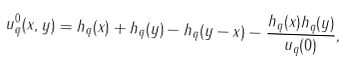<formula> <loc_0><loc_0><loc_500><loc_500>u ^ { 0 } _ { q } ( x , y ) = h _ { q } ( x ) + h _ { q } ( y ) - h _ { q } ( y - x ) - \frac { h _ { q } ( x ) h _ { q } ( y ) } { u _ { q } ( 0 ) } ,</formula> 